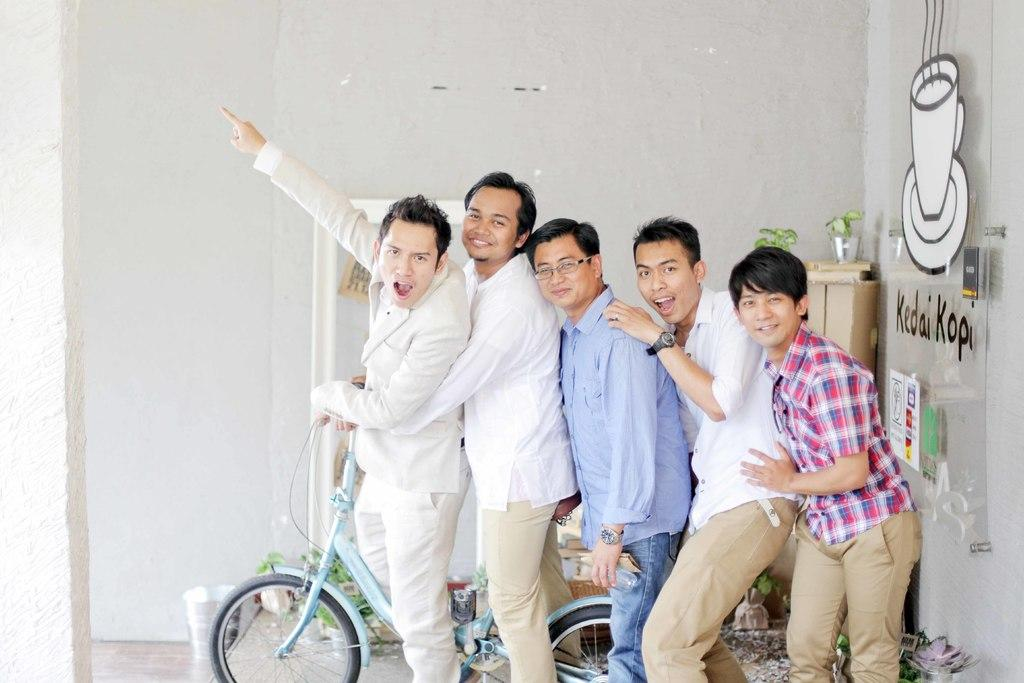How many people are in the image? There are five boys in the image. What are the boys doing in the image? The boys are posing for the camera. What object is present in the image with the boys? The boys are standing with a bicycle. What part of the bicycle is the boys giving advice on in the image? There is no indication in the image that the boys are giving advice about any part of the bicycle. 